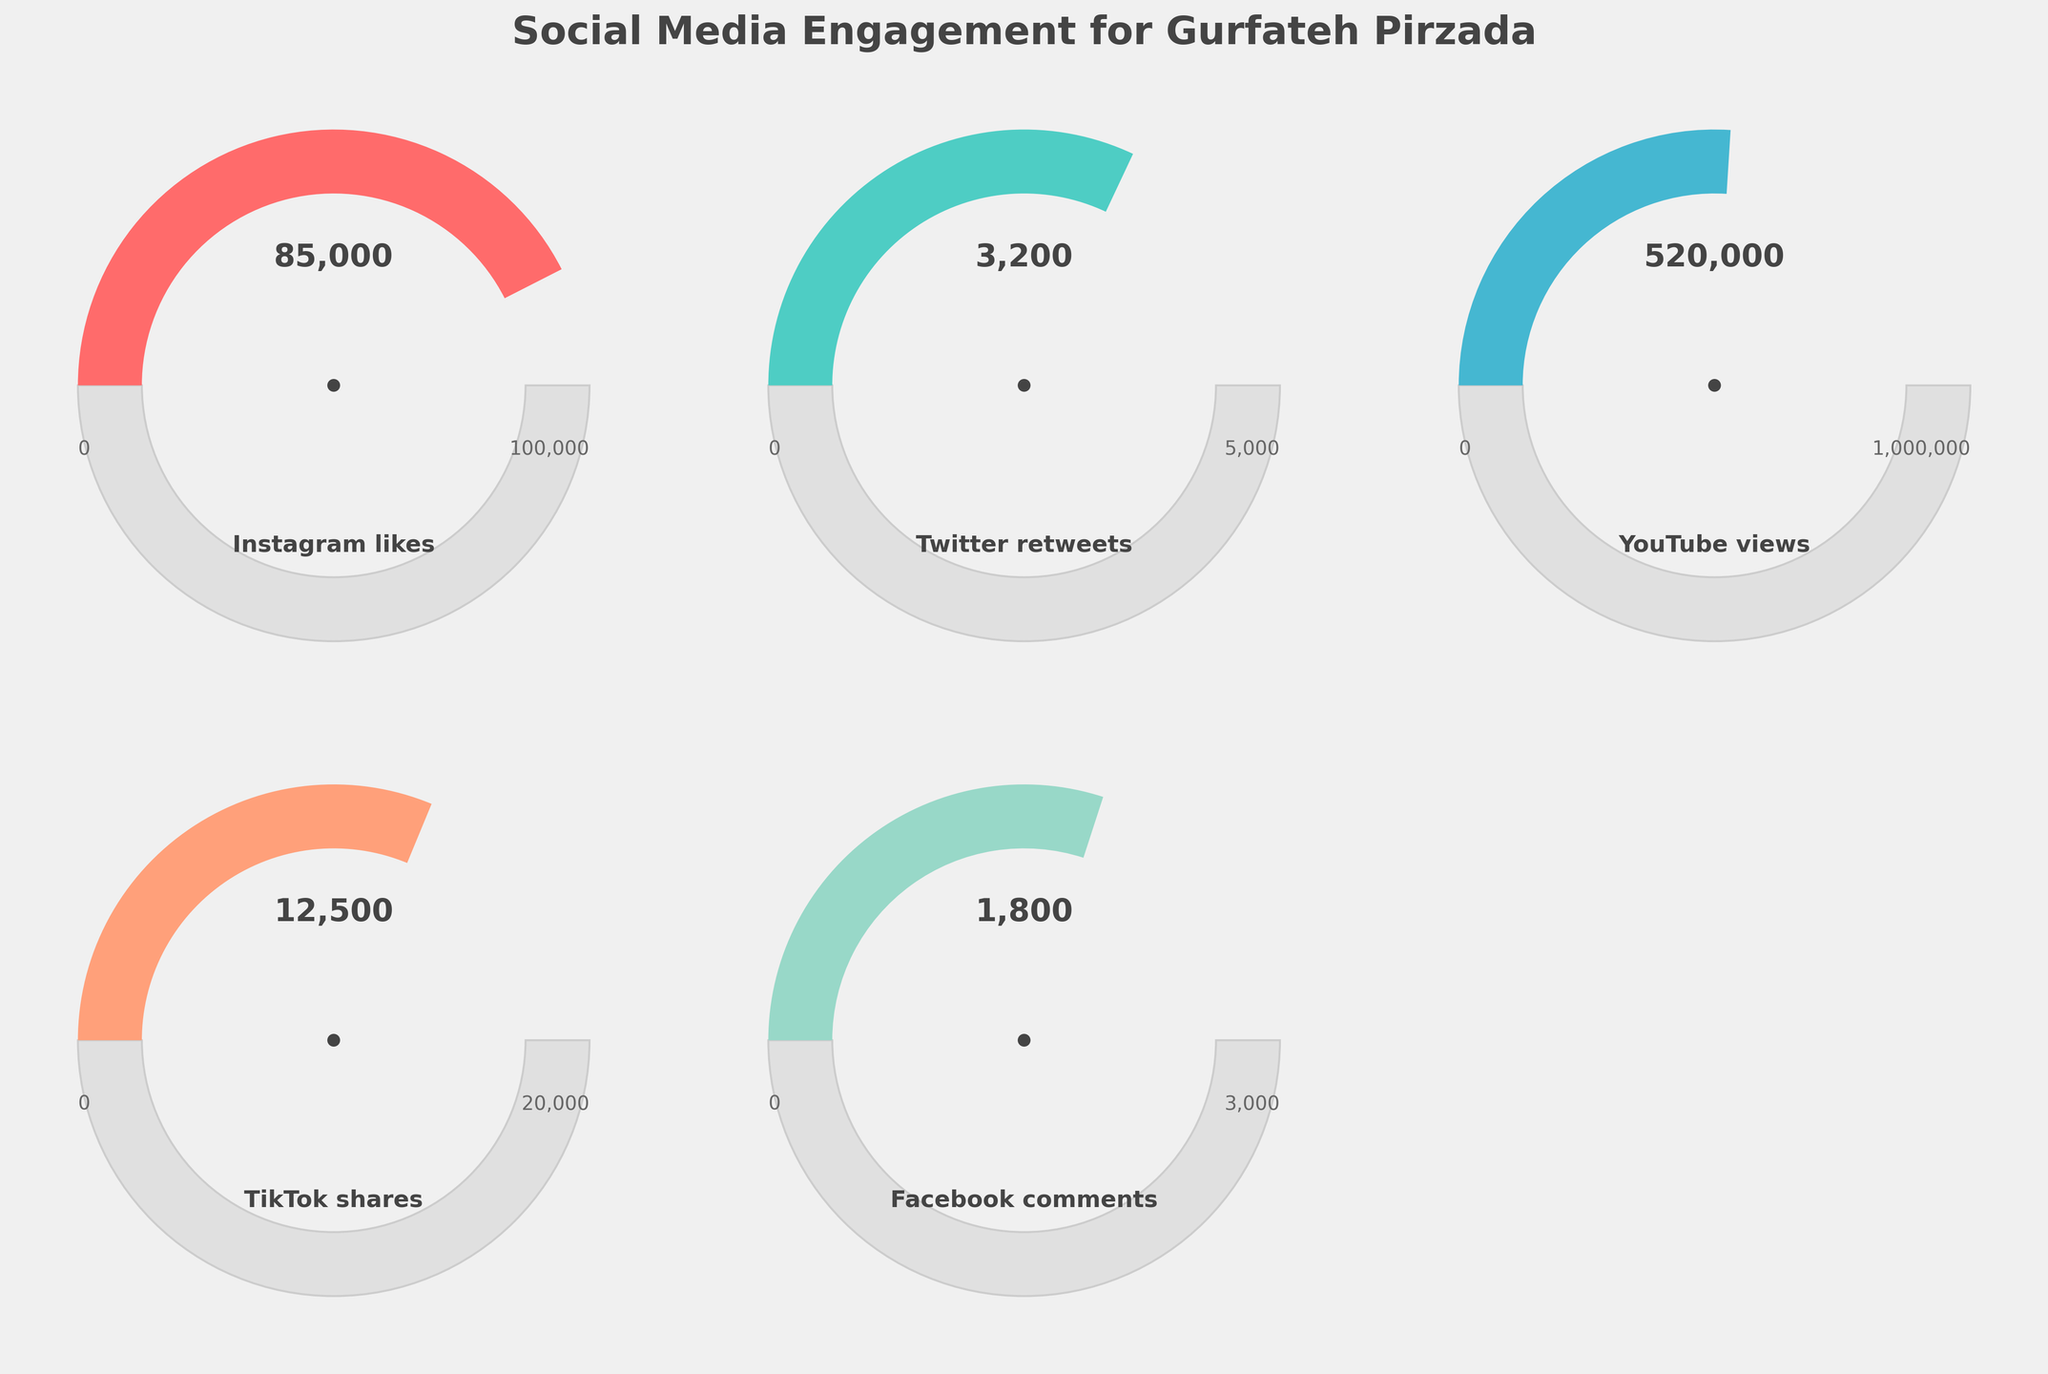What is the engagement level for Instagram likes? The figure shows a gauge chart indicating the social media engagement level for Instagram likes at 85,000 out of a maximum possible 100,000.
Answer: 85,000 Which social media platform has the highest engagement value? By comparing all gauge charts, YouTube has the highest engagement value with 520,000 views.
Answer: YouTube How many more likes on Instagram compared to retweets on Twitter? Subtract the number of Twitter retweets (3,200) from Instagram likes (85,000). 85,000 - 3,200 = 81,800
Answer: 81,800 What is the total engagement value for TikTok shares and Facebook comments? Add the TikTok shares (12,500) and Facebook comments (1,800) for the total engagement value. 12,500 + 1,800 = 14,300
Answer: 14,300 Which platform has the lowest engagement value and what is it? The gauge chart that shows the lowest value is Facebook comments with 1,800 comments.
Answer: Facebook comments How does the engagement on YouTube compare to the maximum possible value? The engagement on YouTube is 520,000 views, which is 52% of the maximum possible value (1,000,000). The gauge chart shows this ratio visually.
Answer: 52% What is the average engagement value across all platforms? Calculate the average by adding all engagement values and dividing by the number of platforms. (85,000 + 3,200 + 520,000 + 12,500 + 1,800) / 5 = 124,500.
Answer: 124,500 By what percentage has Instagram likes reached its maximum possible value? The engagement level for Instagram likes is 85,000 out of 100,000, which is 85,000 / 100,000 = 0.85 or 85%.
Answer: 85% What is the difference between the maximum possible value and the current engagement value for TikTok shares? Subtract the TikTok shares (12,500) from their maximum possible value (20,000). 20,000 - 12,500 = 7,500.
Answer: 7,500 